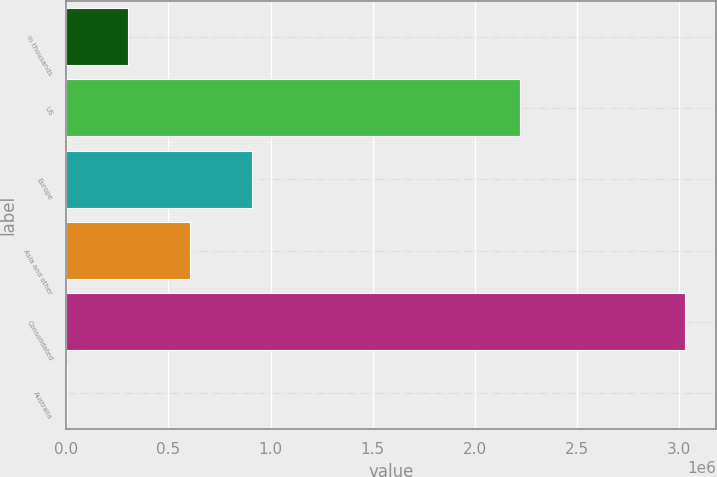<chart> <loc_0><loc_0><loc_500><loc_500><bar_chart><fcel>In thousands<fcel>US<fcel>Europe<fcel>Asia and other<fcel>Consolidated<fcel>Australia<nl><fcel>303772<fcel>2.22286e+06<fcel>909772<fcel>606772<fcel>3.03077e+06<fcel>772<nl></chart> 